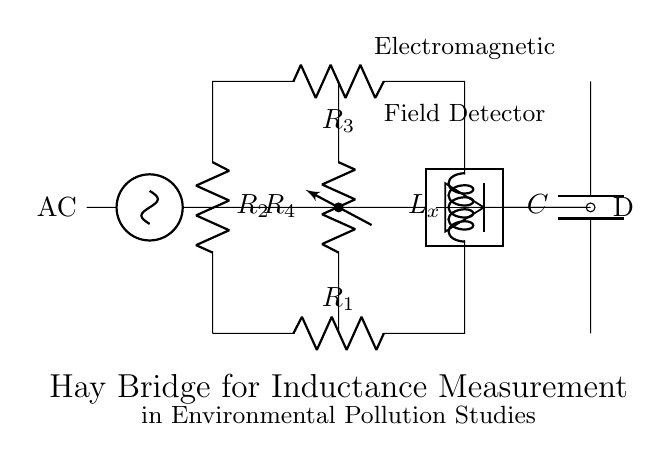What type of voltage source is used in this circuit? The circuit uses a sinusoidal voltage source, indicated by the symbol connected to the left side of the circuit.
Answer: Sinusoidal What components form the bridge in this circuit? The bridge is formed by two resistors and one inductor, specifically R1, R2, and Lx, arranged in a loop configuration.
Answer: R1, R2, Lx What is the purpose of the variable resistor in this circuit? The variable resistor R4 adjusts the balance of the bridge, allowing for fine-tuning of the inductance measurement by altering the resistance in one leg of the bridge.
Answer: Balance How many resistors are present in the circuit? The circuit contains a total of four resistors: R1, R2, R3, and R4.
Answer: Four What type of detector is included in the circuit? The circuit includes an electromagnetic field detector, as labeled on the right-hand side of the bridge.
Answer: Electromagnetic field What is the overall function of the Hay bridge circuit? The Hay bridge circuit is used for measuring inductance, which is crucial for analyzing electromagnetic fields in environmental pollution studies.
Answer: Measuring inductance 